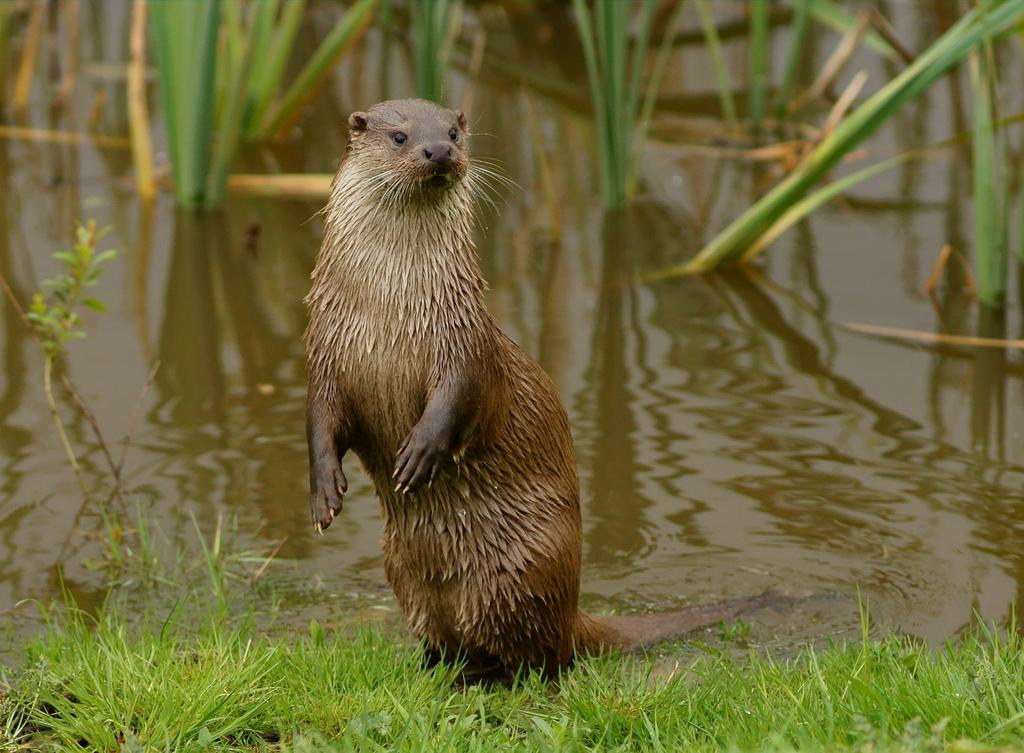What animal is the main subject of the image? There is a sea otter in the image. What is the sea otter doing in the image? The sea otter is standing on the ground. What can be seen in the background of the image? There are plants visible in the water in the background. What type of vegetation is at the bottom of the image? There is grass at the bottom of the image. What type of coat is the sea otter wearing in the image? Sea otters do not wear coats; they have fur for insulation. 